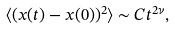Convert formula to latex. <formula><loc_0><loc_0><loc_500><loc_500>\langle ( { x } ( t ) - { x } ( 0 ) ) ^ { 2 } \rangle \sim C t ^ { 2 \nu } ,</formula> 